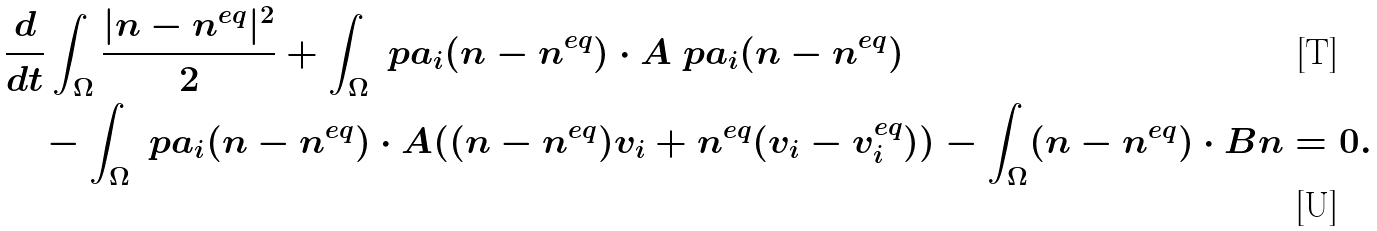<formula> <loc_0><loc_0><loc_500><loc_500>& \frac { d } { d t } \int _ { \Omega } \frac { | n - n ^ { e q } | ^ { 2 } } { 2 } + \int _ { \Omega } \ p a _ { i } ( n - n ^ { e q } ) \cdot A \ p a _ { i } ( n - n ^ { e q } ) \\ & \quad - \int _ { \Omega } \ p a _ { i } ( n - n ^ { e q } ) \cdot A ( ( n - n ^ { e q } ) v _ { i } + n ^ { e q } ( v _ { i } - v _ { i } ^ { e q } ) ) - \int _ { \Omega } ( n - n ^ { e q } ) \cdot B n = 0 .</formula> 